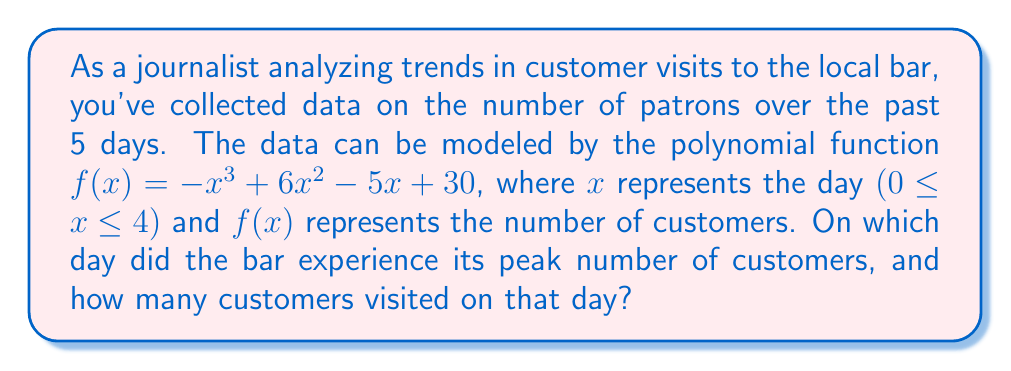What is the answer to this math problem? To find the day with the highest number of customers, we need to find the maximum value of the function $f(x) = -x^3 + 6x^2 - 5x + 30$ within the domain [0, 4].

1) First, let's find the critical points by taking the derivative and setting it equal to zero:
   $f'(x) = -3x^2 + 12x - 5$
   $-3x^2 + 12x - 5 = 0$

2) Solve this quadratic equation:
   $a = -3, b = 12, c = -5$
   $x = \frac{-b \pm \sqrt{b^2 - 4ac}}{2a}$
   $x = \frac{-12 \pm \sqrt{144 - 4(-3)(-5)}}{-6}$
   $x = \frac{-12 \pm \sqrt{144 - 60}}{-6}$
   $x = \frac{-12 \pm \sqrt{84}}{-6}$
   $x = \frac{-12 \pm 9.17}{-6}$

3) This gives us two critical points:
   $x_1 = \frac{-12 + 9.17}{-6} ≈ 0.47$
   $x_2 = \frac{-12 - 9.17}{-6} ≈ 3.53$

4) Since we're dealing with discrete days (0, 1, 2, 3, 4), we need to check the function value at these points and the endpoints of our domain:

   $f(0) = 30$
   $f(1) = -1 + 6 - 5 + 30 = 30$
   $f(2) = -8 + 24 - 10 + 30 = 36$
   $f(3) = -27 + 54 - 15 + 30 = 42$
   $f(4) = -64 + 96 - 20 + 30 = 42$

5) The maximum value occurs when $x = 3$ or $x = 4$, both yielding 42 customers.

6) Since we're asked for a single day, we'll choose the earlier day, which is day 3.
Answer: Day 3, 42 customers 